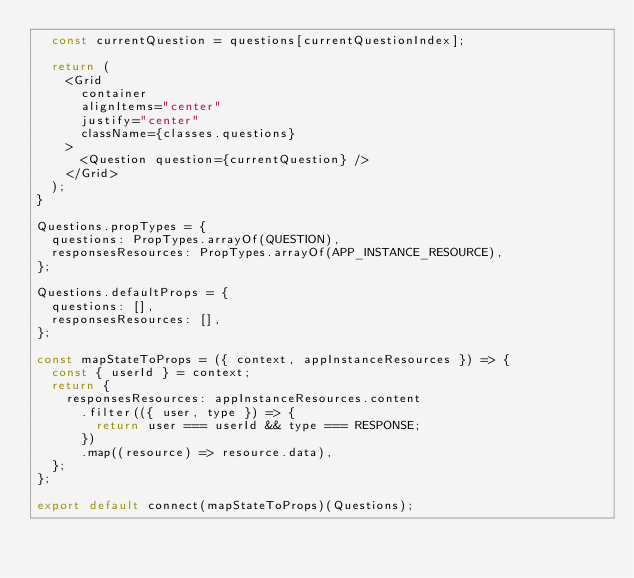Convert code to text. <code><loc_0><loc_0><loc_500><loc_500><_JavaScript_>  const currentQuestion = questions[currentQuestionIndex];

  return (
    <Grid
      container
      alignItems="center"
      justify="center"
      className={classes.questions}
    >
      <Question question={currentQuestion} />
    </Grid>
  );
}

Questions.propTypes = {
  questions: PropTypes.arrayOf(QUESTION),
  responsesResources: PropTypes.arrayOf(APP_INSTANCE_RESOURCE),
};

Questions.defaultProps = {
  questions: [],
  responsesResources: [],
};

const mapStateToProps = ({ context, appInstanceResources }) => {
  const { userId } = context;
  return {
    responsesResources: appInstanceResources.content
      .filter(({ user, type }) => {
        return user === userId && type === RESPONSE;
      })
      .map((resource) => resource.data),
  };
};

export default connect(mapStateToProps)(Questions);
</code> 